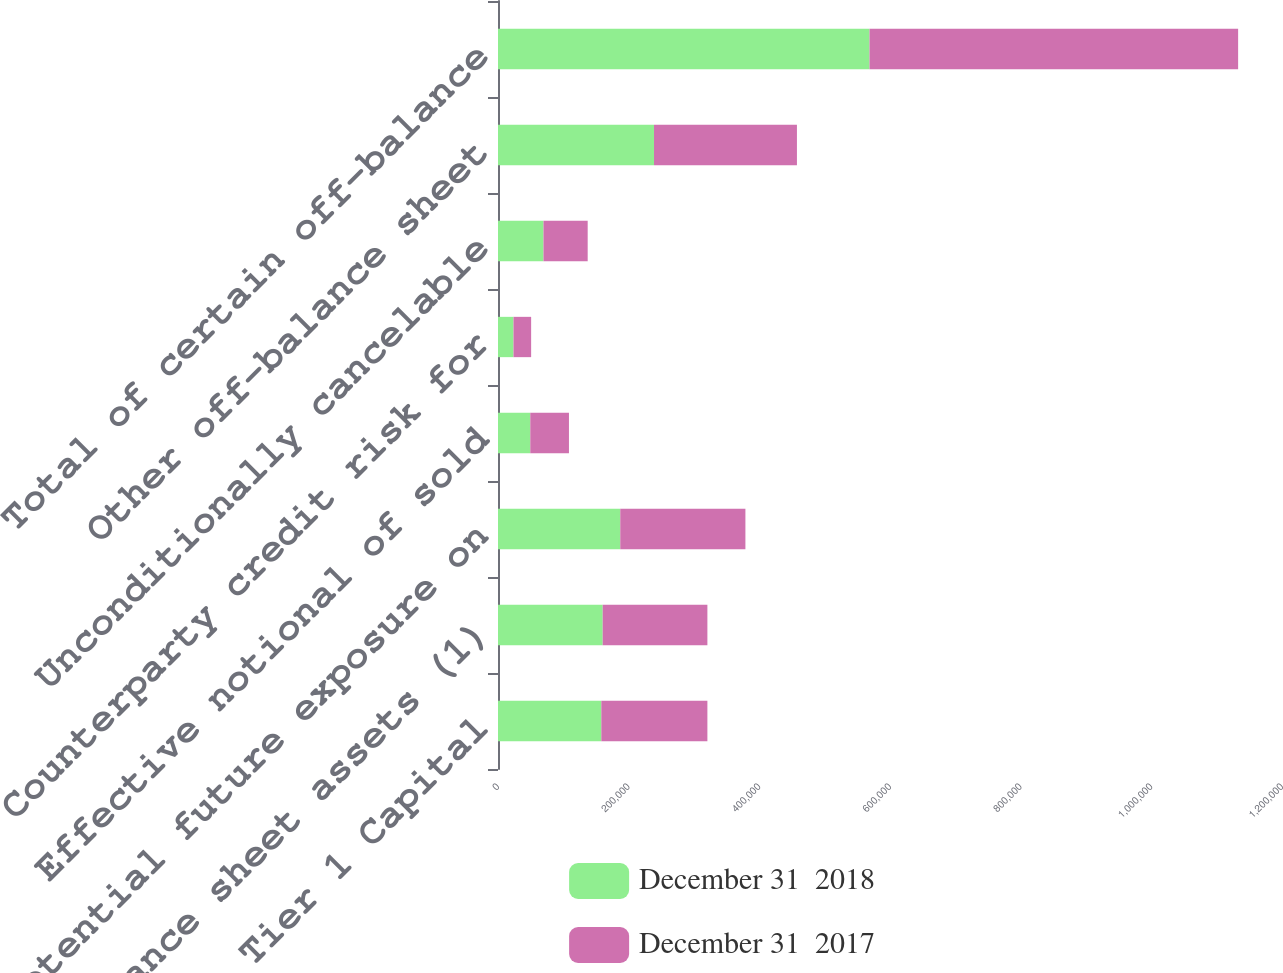Convert chart. <chart><loc_0><loc_0><loc_500><loc_500><stacked_bar_chart><ecel><fcel>Tier 1 Capital<fcel>On-balance sheet assets (1)<fcel>Potential future exposure on<fcel>Effective notional of sold<fcel>Counterparty credit risk for<fcel>Unconditionally cancelable<fcel>Other off-balance sheet<fcel>Total of certain off-balance<nl><fcel>December 31  2018<fcel>158122<fcel>160250<fcel>187130<fcel>49402<fcel>23715<fcel>69630<fcel>238805<fcel>568682<nl><fcel>December 31  2017<fcel>162377<fcel>160250<fcel>191555<fcel>59207<fcel>27005<fcel>67644<fcel>218754<fcel>564165<nl></chart> 